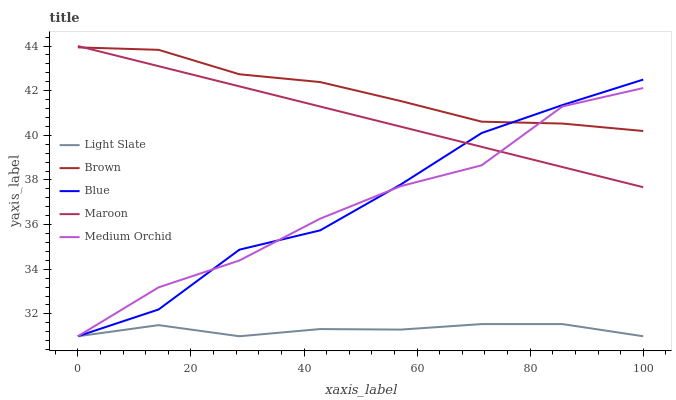Does Light Slate have the minimum area under the curve?
Answer yes or no. Yes. Does Brown have the maximum area under the curve?
Answer yes or no. Yes. Does Medium Orchid have the minimum area under the curve?
Answer yes or no. No. Does Medium Orchid have the maximum area under the curve?
Answer yes or no. No. Is Maroon the smoothest?
Answer yes or no. Yes. Is Medium Orchid the roughest?
Answer yes or no. Yes. Is Brown the smoothest?
Answer yes or no. No. Is Brown the roughest?
Answer yes or no. No. Does Light Slate have the lowest value?
Answer yes or no. Yes. Does Brown have the lowest value?
Answer yes or no. No. Does Maroon have the highest value?
Answer yes or no. Yes. Does Brown have the highest value?
Answer yes or no. No. Is Light Slate less than Maroon?
Answer yes or no. Yes. Is Maroon greater than Light Slate?
Answer yes or no. Yes. Does Medium Orchid intersect Blue?
Answer yes or no. Yes. Is Medium Orchid less than Blue?
Answer yes or no. No. Is Medium Orchid greater than Blue?
Answer yes or no. No. Does Light Slate intersect Maroon?
Answer yes or no. No. 